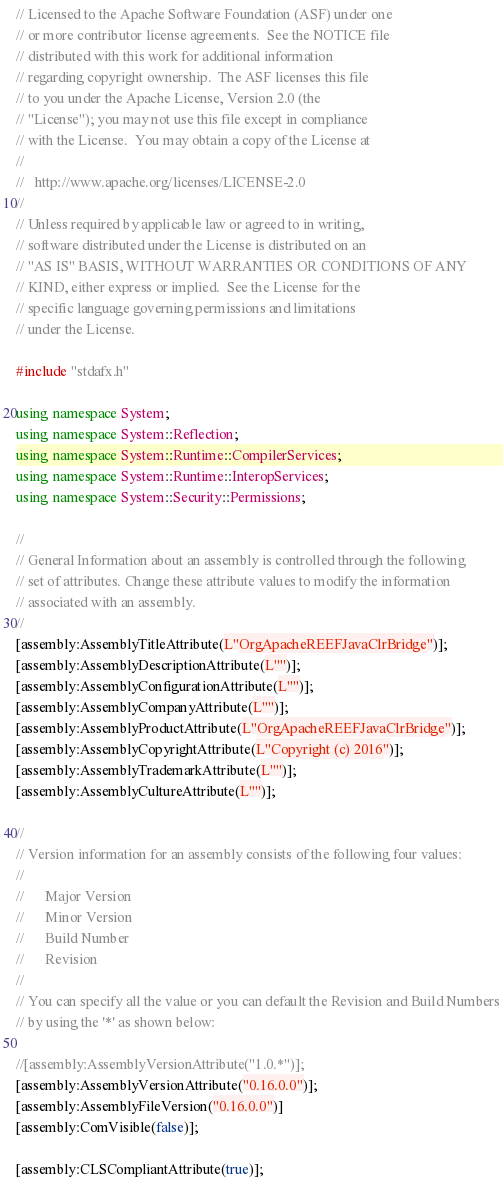Convert code to text. <code><loc_0><loc_0><loc_500><loc_500><_C++_>// Licensed to the Apache Software Foundation (ASF) under one
// or more contributor license agreements.  See the NOTICE file
// distributed with this work for additional information
// regarding copyright ownership.  The ASF licenses this file
// to you under the Apache License, Version 2.0 (the
// "License"); you may not use this file except in compliance
// with the License.  You may obtain a copy of the License at
//
//   http://www.apache.org/licenses/LICENSE-2.0
//
// Unless required by applicable law or agreed to in writing,
// software distributed under the License is distributed on an
// "AS IS" BASIS, WITHOUT WARRANTIES OR CONDITIONS OF ANY
// KIND, either express or implied.  See the License for the
// specific language governing permissions and limitations
// under the License.

#include "stdafx.h"

using namespace System;
using namespace System::Reflection;
using namespace System::Runtime::CompilerServices;
using namespace System::Runtime::InteropServices;
using namespace System::Security::Permissions;

//
// General Information about an assembly is controlled through the following
// set of attributes. Change these attribute values to modify the information
// associated with an assembly.
//
[assembly:AssemblyTitleAttribute(L"OrgApacheREEFJavaClrBridge")];
[assembly:AssemblyDescriptionAttribute(L"")];
[assembly:AssemblyConfigurationAttribute(L"")];
[assembly:AssemblyCompanyAttribute(L"")];
[assembly:AssemblyProductAttribute(L"OrgApacheREEFJavaClrBridge")];
[assembly:AssemblyCopyrightAttribute(L"Copyright (c) 2016")];
[assembly:AssemblyTrademarkAttribute(L"")];
[assembly:AssemblyCultureAttribute(L"")];

//
// Version information for an assembly consists of the following four values:
//
//      Major Version
//      Minor Version
//      Build Number
//      Revision
//
// You can specify all the value or you can default the Revision and Build Numbers
// by using the '*' as shown below:

//[assembly:AssemblyVersionAttribute("1.0.*")];
[assembly:AssemblyVersionAttribute("0.16.0.0")];
[assembly:AssemblyFileVersion("0.16.0.0")]
[assembly:ComVisible(false)];

[assembly:CLSCompliantAttribute(true)];</code> 